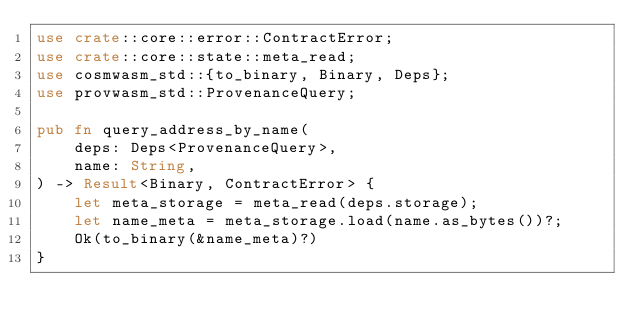Convert code to text. <code><loc_0><loc_0><loc_500><loc_500><_Rust_>use crate::core::error::ContractError;
use crate::core::state::meta_read;
use cosmwasm_std::{to_binary, Binary, Deps};
use provwasm_std::ProvenanceQuery;

pub fn query_address_by_name(
    deps: Deps<ProvenanceQuery>,
    name: String,
) -> Result<Binary, ContractError> {
    let meta_storage = meta_read(deps.storage);
    let name_meta = meta_storage.load(name.as_bytes())?;
    Ok(to_binary(&name_meta)?)
}
</code> 